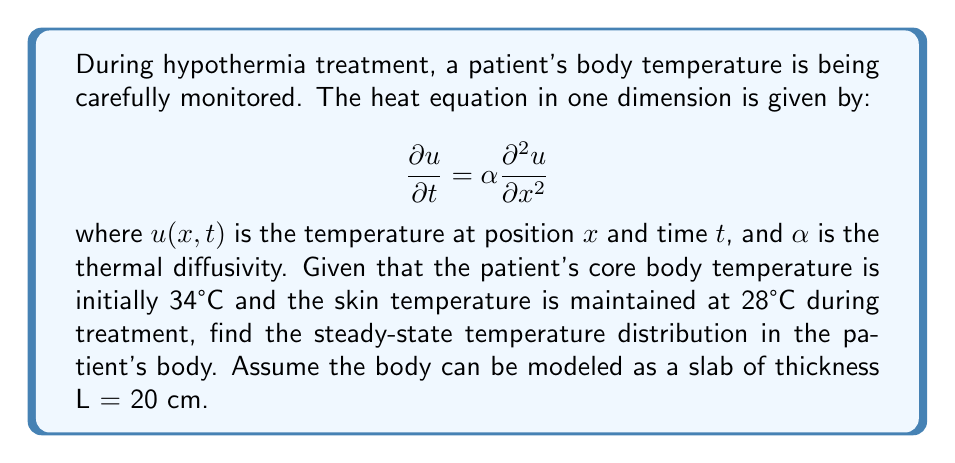Can you answer this question? To solve this problem, we need to find the steady-state solution of the heat equation. In steady-state, the temperature doesn't change with time, so $\frac{\partial u}{\partial t} = 0$. This simplifies our equation to:

$$0 = \alpha \frac{\partial^2 u}{\partial x^2}$$

Integrating twice with respect to x:

$$u(x) = Ax + B$$

where A and B are constants to be determined from the boundary conditions.

Boundary conditions:
1. At x = 0 (core): $u(0) = 34°C$
2. At x = L (skin): $u(L) = 28°C$

Applying these conditions:

1. $u(0) = B = 34°C$
2. $u(L) = AL + 34 = 28°C$

Solving for A:

$$A = \frac{28 - 34}{L} = -\frac{6}{L} = -\frac{6}{20} = -0.3°C/cm$$

Therefore, the steady-state temperature distribution is:

$$u(x) = -0.3x + 34$$

This linear distribution shows that the temperature decreases by 0.3°C for every centimeter from the core to the skin.
Answer: $u(x) = -0.3x + 34$ (°C) 